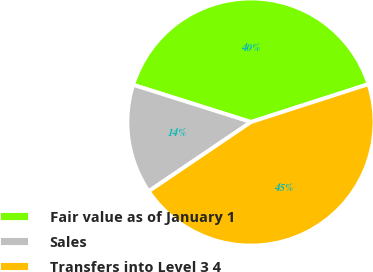Convert chart to OTSL. <chart><loc_0><loc_0><loc_500><loc_500><pie_chart><fcel>Fair value as of January 1<fcel>Sales<fcel>Transfers into Level 3 4<nl><fcel>40.16%<fcel>14.34%<fcel>45.49%<nl></chart> 